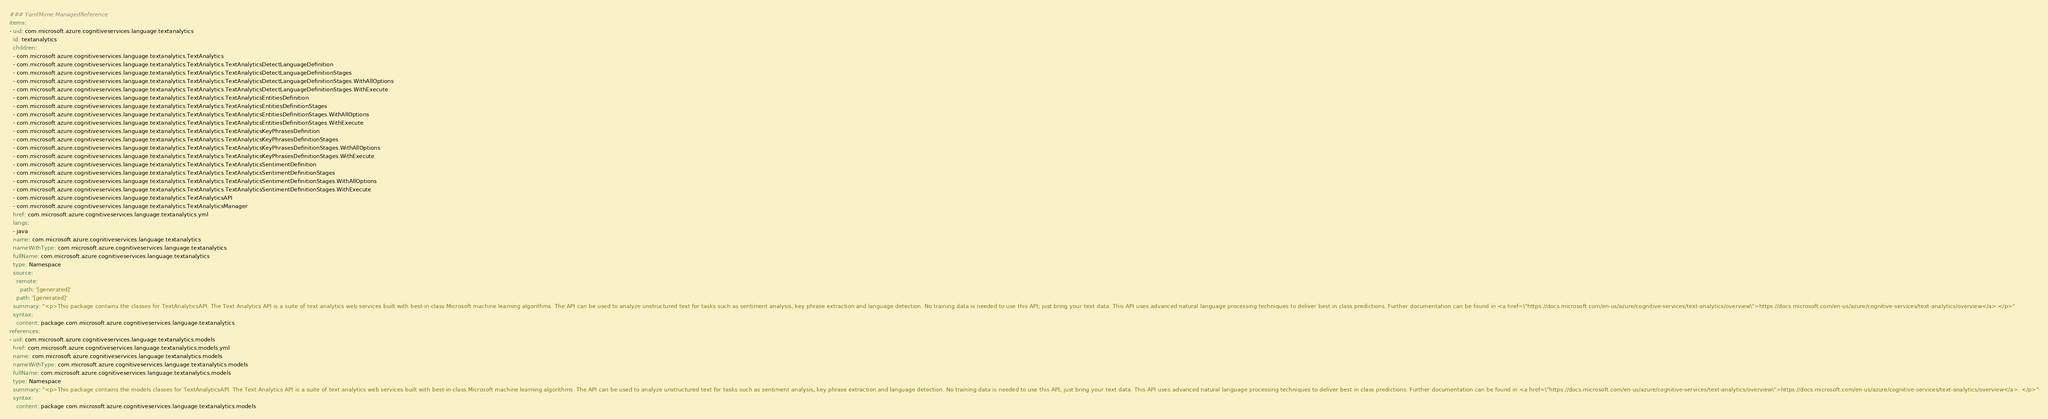<code> <loc_0><loc_0><loc_500><loc_500><_YAML_>### YamlMime:ManagedReference
items:
- uid: com.microsoft.azure.cognitiveservices.language.textanalytics
  id: textanalytics
  children:
  - com.microsoft.azure.cognitiveservices.language.textanalytics.TextAnalytics
  - com.microsoft.azure.cognitiveservices.language.textanalytics.TextAnalytics.TextAnalyticsDetectLanguageDefinition
  - com.microsoft.azure.cognitiveservices.language.textanalytics.TextAnalytics.TextAnalyticsDetectLanguageDefinitionStages
  - com.microsoft.azure.cognitiveservices.language.textanalytics.TextAnalytics.TextAnalyticsDetectLanguageDefinitionStages.WithAllOptions
  - com.microsoft.azure.cognitiveservices.language.textanalytics.TextAnalytics.TextAnalyticsDetectLanguageDefinitionStages.WithExecute
  - com.microsoft.azure.cognitiveservices.language.textanalytics.TextAnalytics.TextAnalyticsEntitiesDefinition
  - com.microsoft.azure.cognitiveservices.language.textanalytics.TextAnalytics.TextAnalyticsEntitiesDefinitionStages
  - com.microsoft.azure.cognitiveservices.language.textanalytics.TextAnalytics.TextAnalyticsEntitiesDefinitionStages.WithAllOptions
  - com.microsoft.azure.cognitiveservices.language.textanalytics.TextAnalytics.TextAnalyticsEntitiesDefinitionStages.WithExecute
  - com.microsoft.azure.cognitiveservices.language.textanalytics.TextAnalytics.TextAnalyticsKeyPhrasesDefinition
  - com.microsoft.azure.cognitiveservices.language.textanalytics.TextAnalytics.TextAnalyticsKeyPhrasesDefinitionStages
  - com.microsoft.azure.cognitiveservices.language.textanalytics.TextAnalytics.TextAnalyticsKeyPhrasesDefinitionStages.WithAllOptions
  - com.microsoft.azure.cognitiveservices.language.textanalytics.TextAnalytics.TextAnalyticsKeyPhrasesDefinitionStages.WithExecute
  - com.microsoft.azure.cognitiveservices.language.textanalytics.TextAnalytics.TextAnalyticsSentimentDefinition
  - com.microsoft.azure.cognitiveservices.language.textanalytics.TextAnalytics.TextAnalyticsSentimentDefinitionStages
  - com.microsoft.azure.cognitiveservices.language.textanalytics.TextAnalytics.TextAnalyticsSentimentDefinitionStages.WithAllOptions
  - com.microsoft.azure.cognitiveservices.language.textanalytics.TextAnalytics.TextAnalyticsSentimentDefinitionStages.WithExecute
  - com.microsoft.azure.cognitiveservices.language.textanalytics.TextAnalyticsAPI
  - com.microsoft.azure.cognitiveservices.language.textanalytics.TextAnalyticsManager
  href: com.microsoft.azure.cognitiveservices.language.textanalytics.yml
  langs:
  - java
  name: com.microsoft.azure.cognitiveservices.language.textanalytics
  nameWithType: com.microsoft.azure.cognitiveservices.language.textanalytics
  fullName: com.microsoft.azure.cognitiveservices.language.textanalytics
  type: Namespace
  source:
    remote:
      path: '[generated]'
    path: '[generated]'
  summary: "<p>This package contains the classes for TextAnalyticsAPI. The Text Analytics API is a suite of text analytics web services built with best-in-class Microsoft machine learning algorithms. The API can be used to analyze unstructured text for tasks such as sentiment analysis, key phrase extraction and language detection. No training data is needed to use this API; just bring your text data. This API uses advanced natural language processing techniques to deliver best in class predictions. Further documentation can be found in <a href=\"https://docs.microsoft.com/en-us/azure/cognitive-services/text-analytics/overview\">https://docs.microsoft.com/en-us/azure/cognitive-services/text-analytics/overview</a>.</p>"
  syntax:
    content: package com.microsoft.azure.cognitiveservices.language.textanalytics
references:
- uid: com.microsoft.azure.cognitiveservices.language.textanalytics.models
  href: com.microsoft.azure.cognitiveservices.language.textanalytics.models.yml
  name: com.microsoft.azure.cognitiveservices.language.textanalytics.models
  nameWithType: com.microsoft.azure.cognitiveservices.language.textanalytics.models
  fullName: com.microsoft.azure.cognitiveservices.language.textanalytics.models
  type: Namespace
  summary: "<p>This package contains the models classes for TextAnalyticsAPI. The Text Analytics API is a suite of text analytics web services built with best-in-class Microsoft machine learning algorithms. The API can be used to analyze unstructured text for tasks such as sentiment analysis, key phrase extraction and language detection. No training data is needed to use this API; just bring your text data. This API uses advanced natural language processing techniques to deliver best in class predictions. Further documentation can be found in <a href=\"https://docs.microsoft.com/en-us/azure/cognitive-services/text-analytics/overview\">https://docs.microsoft.com/en-us/azure/cognitive-services/text-analytics/overview</a>. </p>"
  syntax:
    content: package com.microsoft.azure.cognitiveservices.language.textanalytics.models</code> 